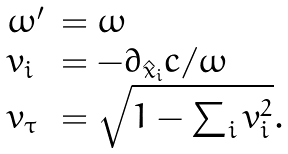<formula> <loc_0><loc_0><loc_500><loc_500>\begin{array} { l l } \omega ^ { \prime } & = \omega \\ v _ { i } & = - \partial _ { \hat { x } _ { i } } c / \omega \\ v _ { \tau } & = \sqrt { 1 - \sum _ { i } v _ { i } ^ { 2 } } . \end{array}</formula> 